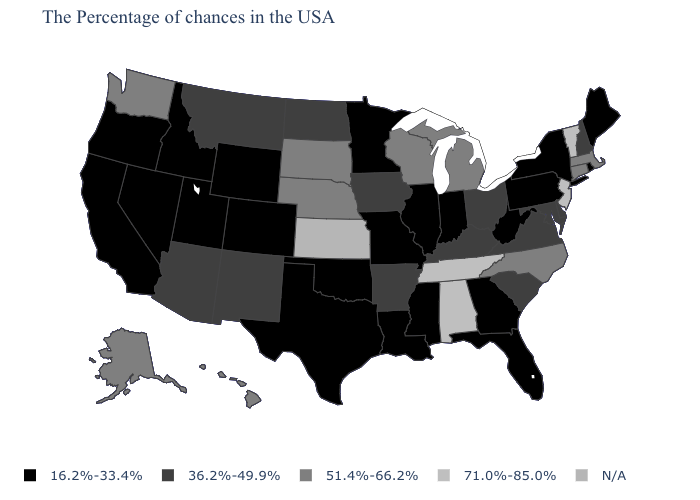Which states hav the highest value in the MidWest?
Short answer required. Michigan, Wisconsin, Nebraska, South Dakota. Which states have the lowest value in the Northeast?
Give a very brief answer. Maine, Rhode Island, New York, Pennsylvania. Does Utah have the lowest value in the USA?
Keep it brief. Yes. How many symbols are there in the legend?
Answer briefly. 5. Among the states that border Alabama , which have the highest value?
Give a very brief answer. Tennessee. What is the value of North Dakota?
Answer briefly. 36.2%-49.9%. Among the states that border Kansas , does Nebraska have the highest value?
Answer briefly. Yes. What is the highest value in states that border New Hampshire?
Short answer required. 71.0%-85.0%. What is the highest value in the USA?
Give a very brief answer. 71.0%-85.0%. What is the value of Montana?
Answer briefly. 36.2%-49.9%. Name the states that have a value in the range 36.2%-49.9%?
Short answer required. New Hampshire, Delaware, Maryland, Virginia, South Carolina, Ohio, Kentucky, Arkansas, Iowa, North Dakota, New Mexico, Montana, Arizona. Name the states that have a value in the range 51.4%-66.2%?
Give a very brief answer. Massachusetts, Connecticut, North Carolina, Michigan, Wisconsin, Nebraska, South Dakota, Washington, Alaska, Hawaii. Does Oregon have the lowest value in the USA?
Keep it brief. Yes. Does Mississippi have the lowest value in the USA?
Short answer required. Yes. Which states have the lowest value in the USA?
Quick response, please. Maine, Rhode Island, New York, Pennsylvania, West Virginia, Florida, Georgia, Indiana, Illinois, Mississippi, Louisiana, Missouri, Minnesota, Oklahoma, Texas, Wyoming, Colorado, Utah, Idaho, Nevada, California, Oregon. 